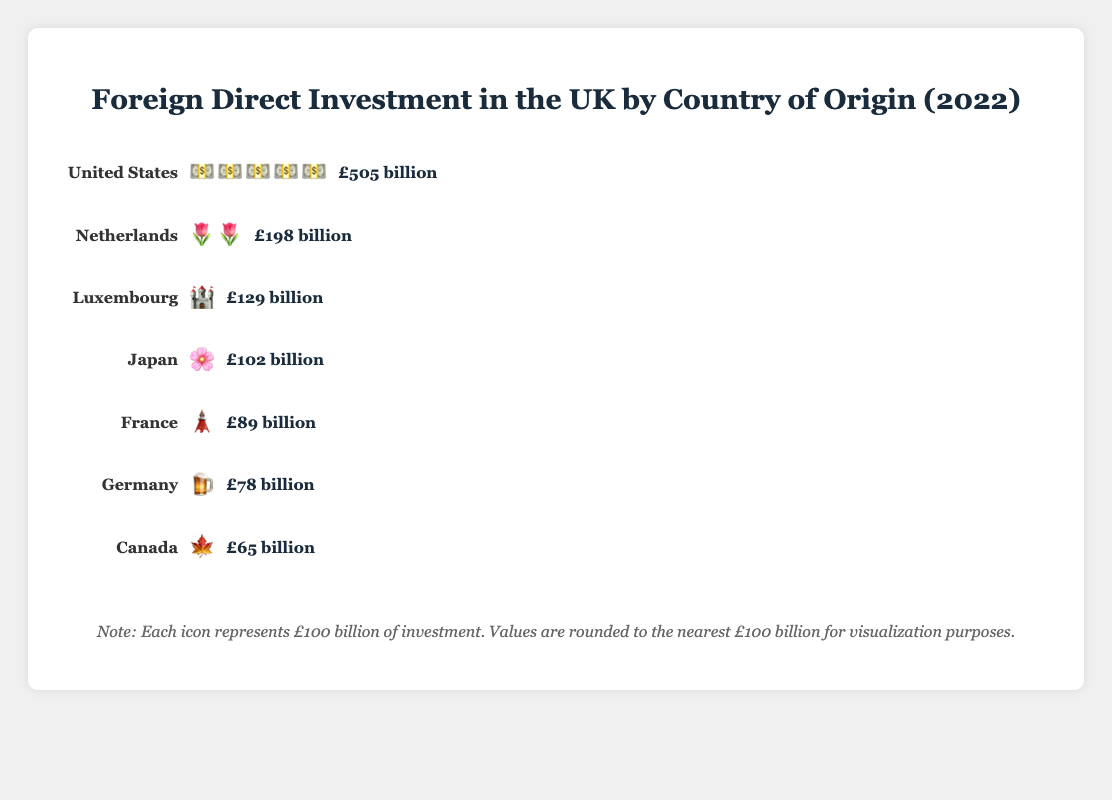What is the title of the figure? The title is usually found at the top of the figure and provides an overview of what the figure represents.
Answer: Foreign Direct Investment in the UK by Country of Origin (2022) Which country has the highest foreign direct investment in the UK? We identify the country with the largest number of icons or highest value. The United States has 505 billion, the highest among the listed countries.
Answer: United States How many billion pounds does the Netherlands invest in the UK? The figure shows icons representing investments, and each icon represents £100 billion. The Netherlands has two icons and a value of £198 billion.
Answer: £198 billion Which country has the least foreign direct investment in the UK? We compare the values listed for each country and find the smallest one. Canada, with £65 billion, has the least investment.
Answer: Canada Which country does £89 billion represent? We look closely at the value £89 billion and match it with the corresponding country label. France is labeled with £89 billion.
Answer: France What is the combined foreign direct investment from Japan and Canada? We sum the values of Japan (£102 billion) and Canada (£65 billion). The total is £102 billion + £65 billion = £167 billion.
Answer: £167 billion How does the foreign direct investment from Germany compare to that from France? We compare the values from Germany (£78 billion) and France (£89 billion). France invests more than Germany.
Answer: France invests more What proportion of the total investment comes from the United States? First, we sum up the total investments: 505 + 198 + 129 + 102 + 89 + 78 + 65 = £1166 billion. The United States' investment is £505 billion. The proportion is computed as (505/1166) * 100 ≈ 43.3%.
Answer: Approximately 43.3% Is the investment from Luxembourg greater than the combined investment from Canada and Germany? We first sum the investments from Canada and Germany: £65 billion + £78 billion = £143 billion. Since Luxembourg invests £129 billion, we compare £129 billion to £143 billion and find it is less.
Answer: No How many countries invest more than £100 billion in the UK? We count the countries whose investment amounts are greater than £100 billion: United States (£505 billion), Netherlands (£198 billion), and Japan (£102 billion). Three countries fit this criterion.
Answer: 3 